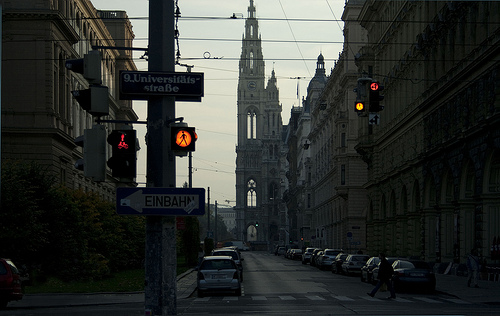What architectural style can be seen in the building in the distance? The building in the distance features a Gothic architectural style, recognizable by its pointed arches and elaborate, ornate details, which is common in many European churches. 